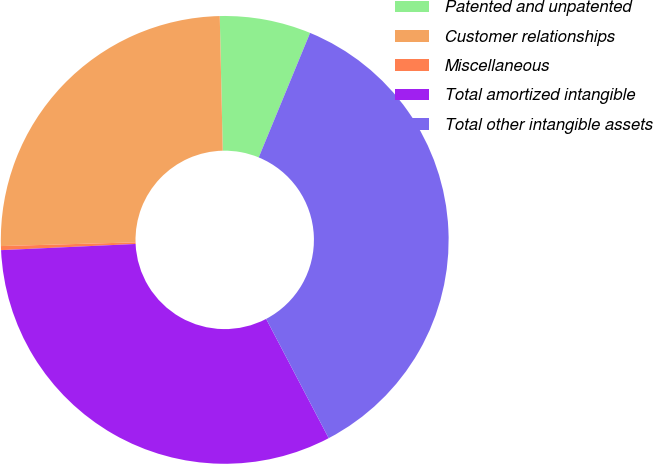Convert chart to OTSL. <chart><loc_0><loc_0><loc_500><loc_500><pie_chart><fcel>Patented and unpatented<fcel>Customer relationships<fcel>Miscellaneous<fcel>Total amortized intangible<fcel>Total other intangible assets<nl><fcel>6.58%<fcel>25.09%<fcel>0.29%<fcel>31.96%<fcel>36.09%<nl></chart> 